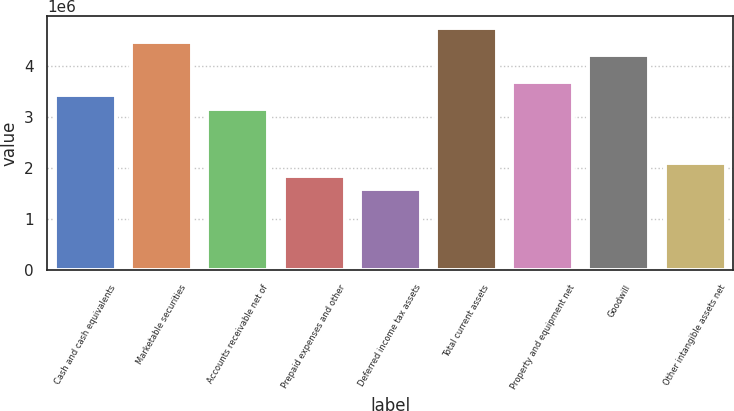<chart> <loc_0><loc_0><loc_500><loc_500><bar_chart><fcel>Cash and cash equivalents<fcel>Marketable securities<fcel>Accounts receivable net of<fcel>Prepaid expenses and other<fcel>Deferred income tax assets<fcel>Total current assets<fcel>Property and equipment net<fcel>Goodwill<fcel>Other intangible assets net<nl><fcel>3.41968e+06<fcel>4.4718e+06<fcel>3.15665e+06<fcel>1.84151e+06<fcel>1.57848e+06<fcel>4.73483e+06<fcel>3.68271e+06<fcel>4.20877e+06<fcel>2.10454e+06<nl></chart> 